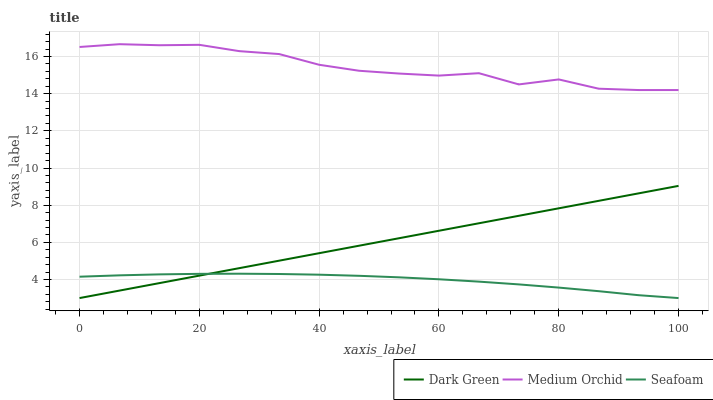Does Seafoam have the minimum area under the curve?
Answer yes or no. Yes. Does Medium Orchid have the maximum area under the curve?
Answer yes or no. Yes. Does Dark Green have the minimum area under the curve?
Answer yes or no. No. Does Dark Green have the maximum area under the curve?
Answer yes or no. No. Is Dark Green the smoothest?
Answer yes or no. Yes. Is Medium Orchid the roughest?
Answer yes or no. Yes. Is Seafoam the smoothest?
Answer yes or no. No. Is Seafoam the roughest?
Answer yes or no. No. Does Seafoam have the lowest value?
Answer yes or no. Yes. Does Medium Orchid have the highest value?
Answer yes or no. Yes. Does Dark Green have the highest value?
Answer yes or no. No. Is Seafoam less than Medium Orchid?
Answer yes or no. Yes. Is Medium Orchid greater than Dark Green?
Answer yes or no. Yes. Does Dark Green intersect Seafoam?
Answer yes or no. Yes. Is Dark Green less than Seafoam?
Answer yes or no. No. Is Dark Green greater than Seafoam?
Answer yes or no. No. Does Seafoam intersect Medium Orchid?
Answer yes or no. No. 